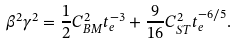Convert formula to latex. <formula><loc_0><loc_0><loc_500><loc_500>\beta ^ { 2 } \gamma ^ { 2 } = \frac { 1 } { 2 } C _ { B M } ^ { 2 } t _ { e } ^ { - 3 } + \frac { 9 } { 1 6 } C _ { S T } ^ { 2 } t _ { e } ^ { - 6 / 5 } .</formula> 